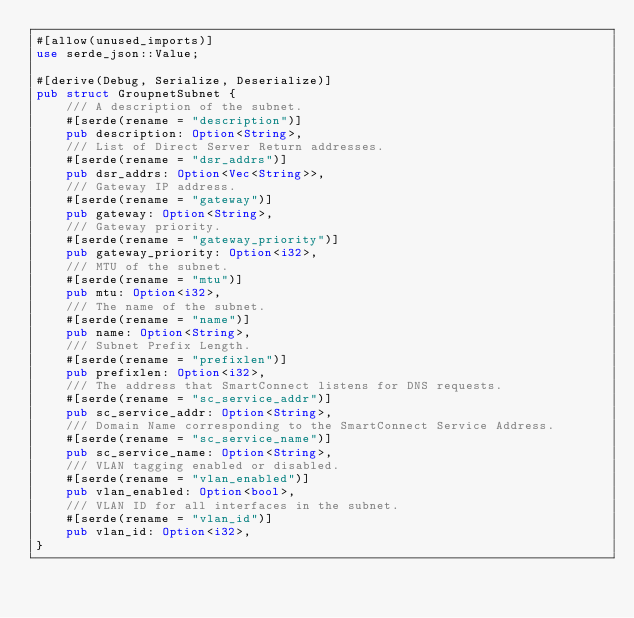Convert code to text. <code><loc_0><loc_0><loc_500><loc_500><_Rust_>#[allow(unused_imports)]
use serde_json::Value;

#[derive(Debug, Serialize, Deserialize)]
pub struct GroupnetSubnet {
    /// A description of the subnet.
    #[serde(rename = "description")]
    pub description: Option<String>,
    /// List of Direct Server Return addresses.
    #[serde(rename = "dsr_addrs")]
    pub dsr_addrs: Option<Vec<String>>,
    /// Gateway IP address.
    #[serde(rename = "gateway")]
    pub gateway: Option<String>,
    /// Gateway priority.
    #[serde(rename = "gateway_priority")]
    pub gateway_priority: Option<i32>,
    /// MTU of the subnet.
    #[serde(rename = "mtu")]
    pub mtu: Option<i32>,
    /// The name of the subnet.
    #[serde(rename = "name")]
    pub name: Option<String>,
    /// Subnet Prefix Length.
    #[serde(rename = "prefixlen")]
    pub prefixlen: Option<i32>,
    /// The address that SmartConnect listens for DNS requests.
    #[serde(rename = "sc_service_addr")]
    pub sc_service_addr: Option<String>,
    /// Domain Name corresponding to the SmartConnect Service Address.
    #[serde(rename = "sc_service_name")]
    pub sc_service_name: Option<String>,
    /// VLAN tagging enabled or disabled.
    #[serde(rename = "vlan_enabled")]
    pub vlan_enabled: Option<bool>,
    /// VLAN ID for all interfaces in the subnet.
    #[serde(rename = "vlan_id")]
    pub vlan_id: Option<i32>,
}
</code> 